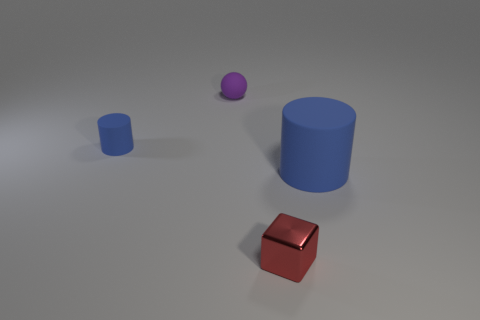What is the relative size of the objects in the image? Relative to each other, the tall blue cylinder is the largest object in the image, followed by the large brown cube. The small blue cube is significantly smaller than these two, and the small purple sphere is the smallest object present. 